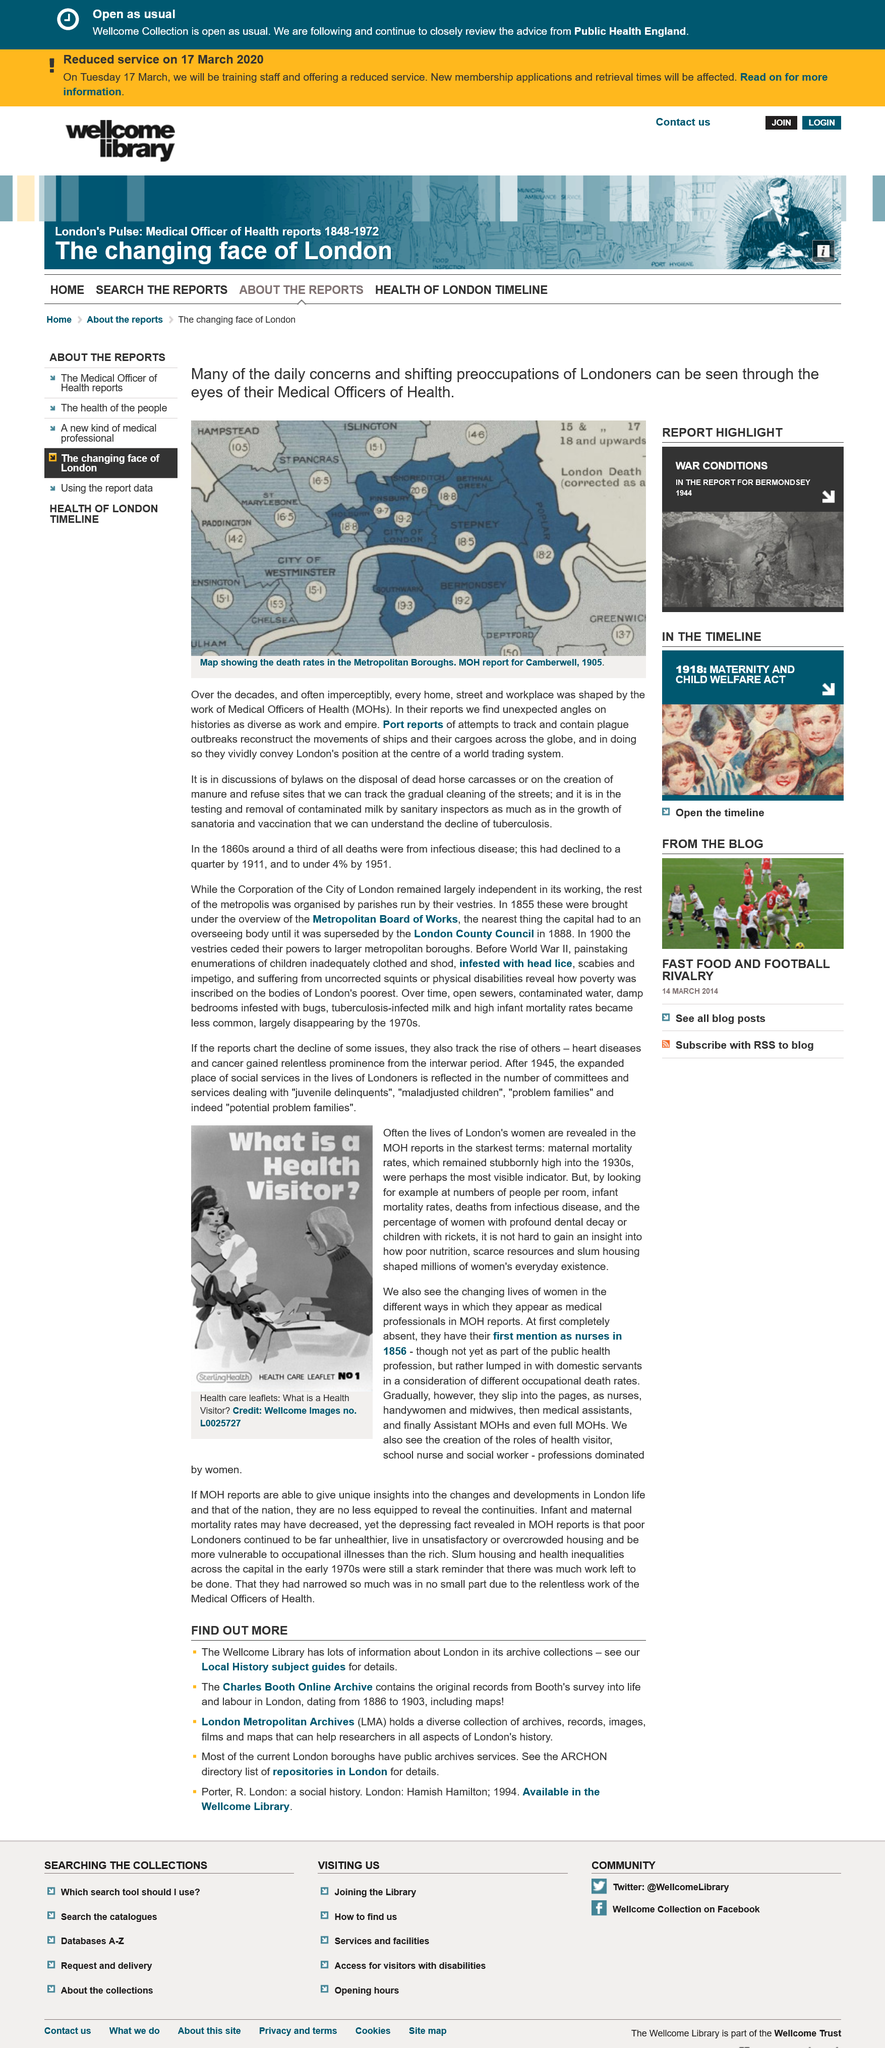Specify some key components in this picture. Poor nutrition has significantly impacted the daily lives of millions of women. The fact is that maternal mortality was high in the 1930's, and it is a widely accepted reality. The maternal mortality rates were the most visible indicator of the lives of London's women during the period under investigation. 